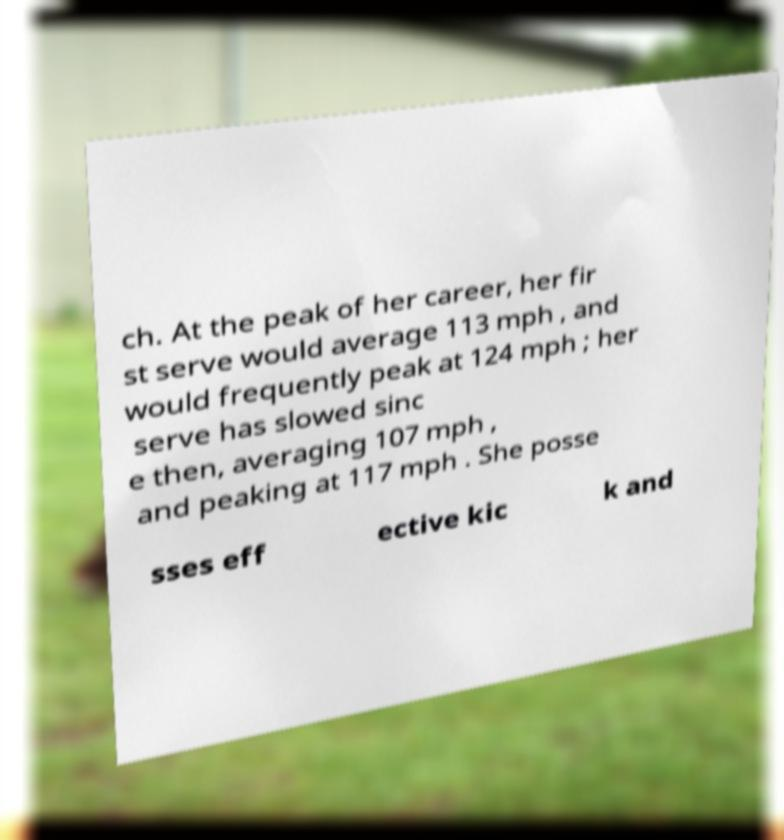For documentation purposes, I need the text within this image transcribed. Could you provide that? ch. At the peak of her career, her fir st serve would average 113 mph , and would frequently peak at 124 mph ; her serve has slowed sinc e then, averaging 107 mph , and peaking at 117 mph . She posse sses eff ective kic k and 